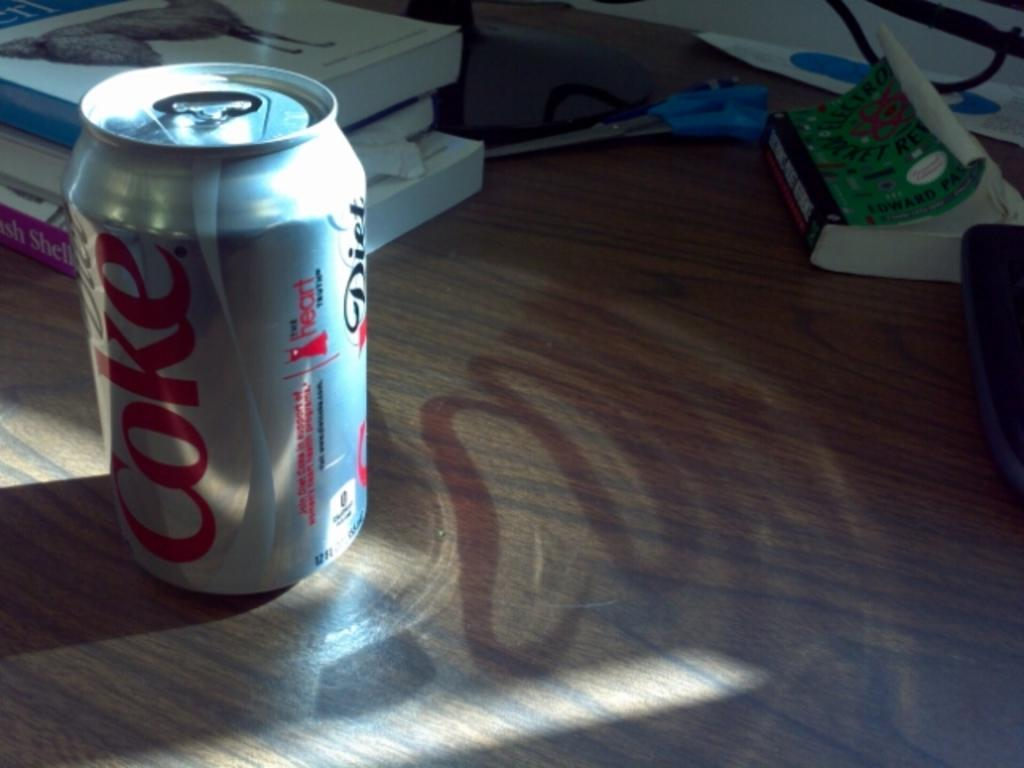<image>
Write a terse but informative summary of the picture. The reflection of a diet Coke is lit onto the table. 